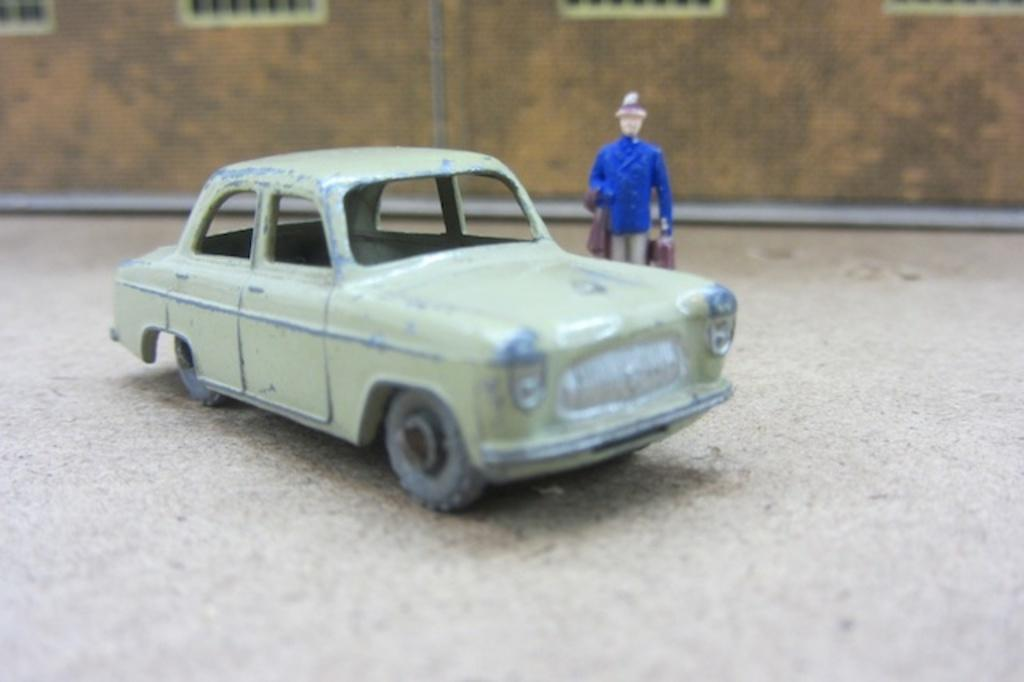What type of toy is present in the image? There is a toy car in the image. What other toy can be seen in the image? There is a doll in the image. Can you describe the position of the doll in relation to the toy car? The doll is beside the toy car. What design can be seen on the giants in the image? There are no giants present in the image, so there is no design to describe. 